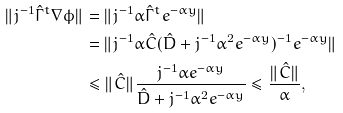<formula> <loc_0><loc_0><loc_500><loc_500>\| j ^ { - 1 } \hat { \Gamma } ^ { t } \nabla \phi \| & = \| j ^ { - 1 } \alpha \hat { \Gamma } ^ { t } e ^ { - \alpha y } \| \\ & = \| j ^ { - 1 } \alpha \hat { C } ( \hat { D } + j ^ { - 1 } \alpha ^ { 2 } e ^ { - \alpha y } ) ^ { - 1 } e ^ { - \alpha y } \| \\ & \leq \| \hat { C } \| \frac { j ^ { - 1 } \alpha e ^ { - \alpha y } } { \hat { D } + j ^ { - 1 } \alpha ^ { 2 } e ^ { - \alpha y } } \leq \frac { \| \hat { C } \| } { \alpha } ,</formula> 